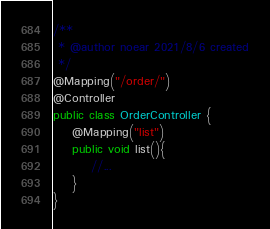Convert code to text. <code><loc_0><loc_0><loc_500><loc_500><_Java_>/**
 * @author noear 2021/8/6 created
 */
@Mapping("/order/")
@Controller
public class OrderController {
    @Mapping("list")
    public void list(){
        //...
    }
}
</code> 